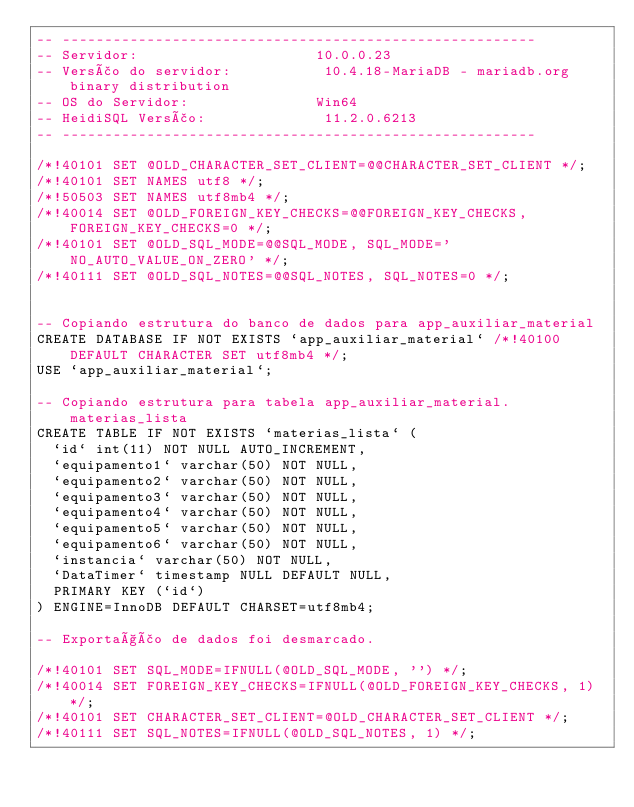Convert code to text. <code><loc_0><loc_0><loc_500><loc_500><_SQL_>-- --------------------------------------------------------
-- Servidor:                     10.0.0.23
-- Versão do servidor:           10.4.18-MariaDB - mariadb.org binary distribution
-- OS do Servidor:               Win64
-- HeidiSQL Versão:              11.2.0.6213
-- --------------------------------------------------------

/*!40101 SET @OLD_CHARACTER_SET_CLIENT=@@CHARACTER_SET_CLIENT */;
/*!40101 SET NAMES utf8 */;
/*!50503 SET NAMES utf8mb4 */;
/*!40014 SET @OLD_FOREIGN_KEY_CHECKS=@@FOREIGN_KEY_CHECKS, FOREIGN_KEY_CHECKS=0 */;
/*!40101 SET @OLD_SQL_MODE=@@SQL_MODE, SQL_MODE='NO_AUTO_VALUE_ON_ZERO' */;
/*!40111 SET @OLD_SQL_NOTES=@@SQL_NOTES, SQL_NOTES=0 */;


-- Copiando estrutura do banco de dados para app_auxiliar_material
CREATE DATABASE IF NOT EXISTS `app_auxiliar_material` /*!40100 DEFAULT CHARACTER SET utf8mb4 */;
USE `app_auxiliar_material`;

-- Copiando estrutura para tabela app_auxiliar_material.materias_lista
CREATE TABLE IF NOT EXISTS `materias_lista` (
  `id` int(11) NOT NULL AUTO_INCREMENT,
  `equipamento1` varchar(50) NOT NULL,
  `equipamento2` varchar(50) NOT NULL,
  `equipamento3` varchar(50) NOT NULL,
  `equipamento4` varchar(50) NOT NULL,
  `equipamento5` varchar(50) NOT NULL,
  `equipamento6` varchar(50) NOT NULL,
  `instancia` varchar(50) NOT NULL,
  `DataTimer` timestamp NULL DEFAULT NULL,
  PRIMARY KEY (`id`)
) ENGINE=InnoDB DEFAULT CHARSET=utf8mb4;

-- Exportação de dados foi desmarcado.

/*!40101 SET SQL_MODE=IFNULL(@OLD_SQL_MODE, '') */;
/*!40014 SET FOREIGN_KEY_CHECKS=IFNULL(@OLD_FOREIGN_KEY_CHECKS, 1) */;
/*!40101 SET CHARACTER_SET_CLIENT=@OLD_CHARACTER_SET_CLIENT */;
/*!40111 SET SQL_NOTES=IFNULL(@OLD_SQL_NOTES, 1) */;
</code> 